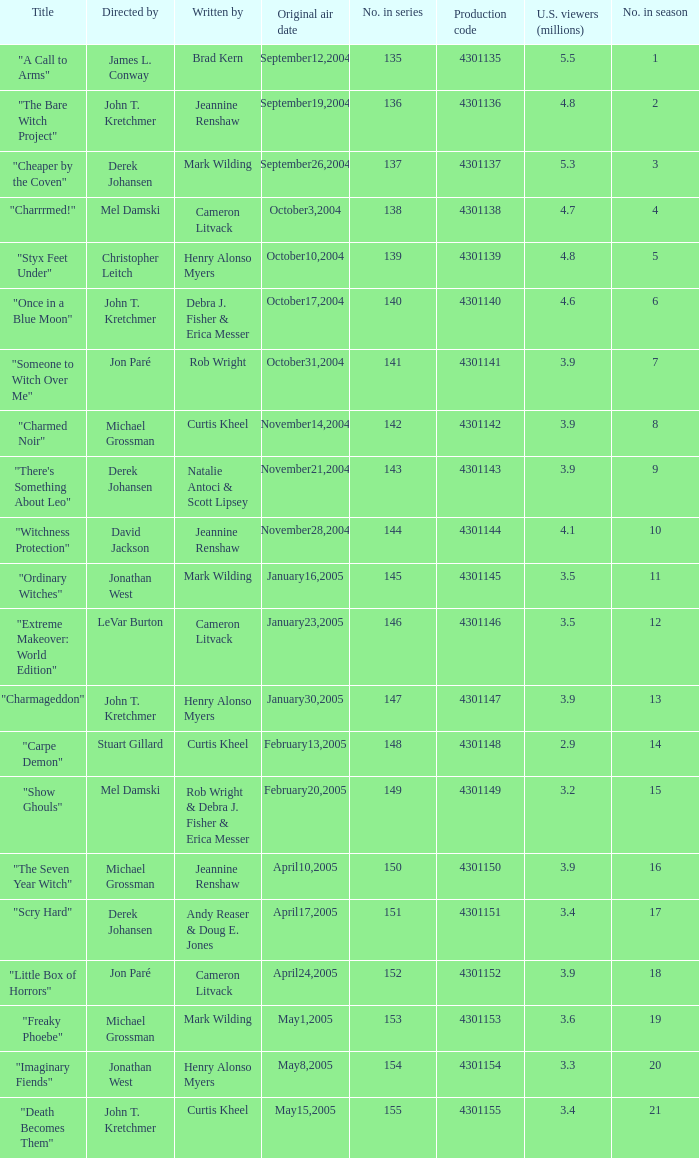In season number 3,  who were the writers? Mark Wilding. 